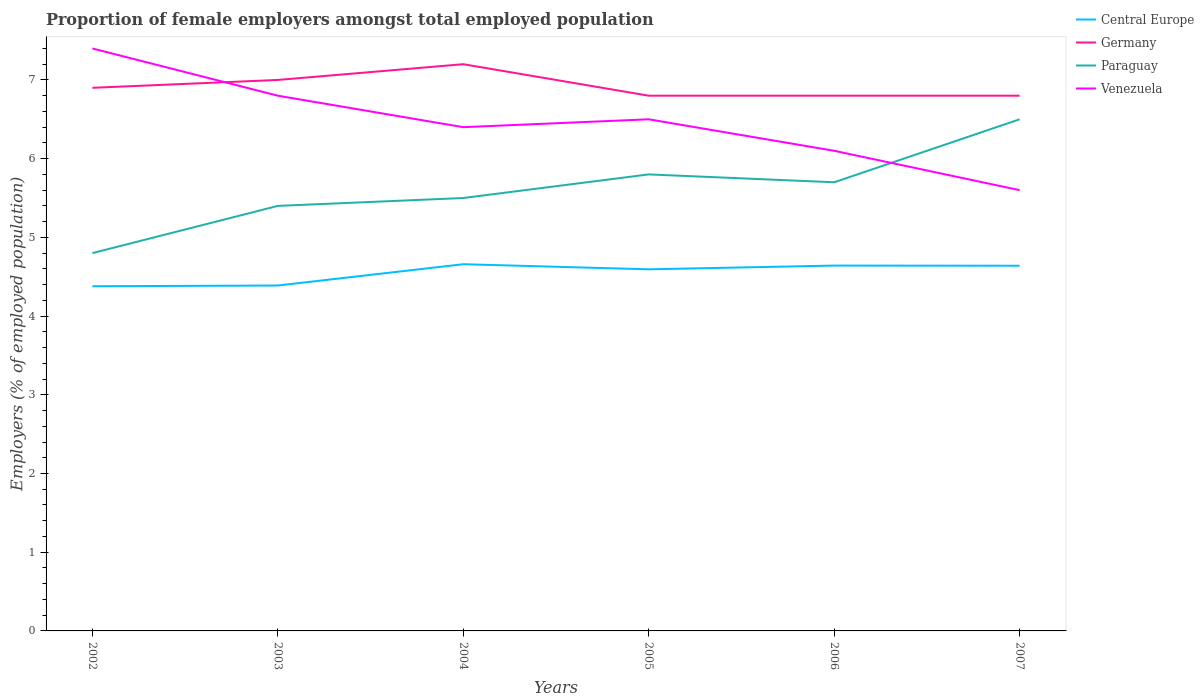How many different coloured lines are there?
Ensure brevity in your answer.  4. Does the line corresponding to Germany intersect with the line corresponding to Venezuela?
Your answer should be compact. Yes. Is the number of lines equal to the number of legend labels?
Ensure brevity in your answer.  Yes. Across all years, what is the maximum proportion of female employers in Paraguay?
Provide a short and direct response. 4.8. What is the total proportion of female employers in Germany in the graph?
Provide a succinct answer. 0.1. What is the difference between the highest and the second highest proportion of female employers in Venezuela?
Make the answer very short. 1.8. How many years are there in the graph?
Your answer should be very brief. 6. Are the values on the major ticks of Y-axis written in scientific E-notation?
Your answer should be very brief. No. Does the graph contain grids?
Provide a succinct answer. No. How are the legend labels stacked?
Provide a succinct answer. Vertical. What is the title of the graph?
Your response must be concise. Proportion of female employers amongst total employed population. Does "Saudi Arabia" appear as one of the legend labels in the graph?
Offer a very short reply. No. What is the label or title of the X-axis?
Your answer should be very brief. Years. What is the label or title of the Y-axis?
Provide a short and direct response. Employers (% of employed population). What is the Employers (% of employed population) of Central Europe in 2002?
Provide a short and direct response. 4.38. What is the Employers (% of employed population) in Germany in 2002?
Provide a short and direct response. 6.9. What is the Employers (% of employed population) of Paraguay in 2002?
Your answer should be compact. 4.8. What is the Employers (% of employed population) of Venezuela in 2002?
Keep it short and to the point. 7.4. What is the Employers (% of employed population) of Central Europe in 2003?
Your response must be concise. 4.39. What is the Employers (% of employed population) of Paraguay in 2003?
Make the answer very short. 5.4. What is the Employers (% of employed population) in Venezuela in 2003?
Provide a short and direct response. 6.8. What is the Employers (% of employed population) in Central Europe in 2004?
Keep it short and to the point. 4.66. What is the Employers (% of employed population) of Germany in 2004?
Provide a succinct answer. 7.2. What is the Employers (% of employed population) in Venezuela in 2004?
Provide a succinct answer. 6.4. What is the Employers (% of employed population) of Central Europe in 2005?
Provide a succinct answer. 4.59. What is the Employers (% of employed population) of Germany in 2005?
Your response must be concise. 6.8. What is the Employers (% of employed population) in Paraguay in 2005?
Provide a succinct answer. 5.8. What is the Employers (% of employed population) of Central Europe in 2006?
Provide a short and direct response. 4.64. What is the Employers (% of employed population) of Germany in 2006?
Your answer should be very brief. 6.8. What is the Employers (% of employed population) in Paraguay in 2006?
Keep it short and to the point. 5.7. What is the Employers (% of employed population) in Venezuela in 2006?
Provide a short and direct response. 6.1. What is the Employers (% of employed population) of Central Europe in 2007?
Provide a short and direct response. 4.64. What is the Employers (% of employed population) in Germany in 2007?
Make the answer very short. 6.8. What is the Employers (% of employed population) in Paraguay in 2007?
Your answer should be compact. 6.5. What is the Employers (% of employed population) of Venezuela in 2007?
Your response must be concise. 5.6. Across all years, what is the maximum Employers (% of employed population) in Central Europe?
Your answer should be compact. 4.66. Across all years, what is the maximum Employers (% of employed population) in Germany?
Make the answer very short. 7.2. Across all years, what is the maximum Employers (% of employed population) in Venezuela?
Provide a succinct answer. 7.4. Across all years, what is the minimum Employers (% of employed population) of Central Europe?
Your answer should be compact. 4.38. Across all years, what is the minimum Employers (% of employed population) in Germany?
Offer a very short reply. 6.8. Across all years, what is the minimum Employers (% of employed population) of Paraguay?
Provide a short and direct response. 4.8. Across all years, what is the minimum Employers (% of employed population) in Venezuela?
Your response must be concise. 5.6. What is the total Employers (% of employed population) in Central Europe in the graph?
Give a very brief answer. 27.3. What is the total Employers (% of employed population) of Germany in the graph?
Give a very brief answer. 41.5. What is the total Employers (% of employed population) in Paraguay in the graph?
Ensure brevity in your answer.  33.7. What is the total Employers (% of employed population) of Venezuela in the graph?
Your answer should be compact. 38.8. What is the difference between the Employers (% of employed population) of Central Europe in 2002 and that in 2003?
Your response must be concise. -0.01. What is the difference between the Employers (% of employed population) in Germany in 2002 and that in 2003?
Ensure brevity in your answer.  -0.1. What is the difference between the Employers (% of employed population) of Paraguay in 2002 and that in 2003?
Provide a short and direct response. -0.6. What is the difference between the Employers (% of employed population) in Venezuela in 2002 and that in 2003?
Your answer should be very brief. 0.6. What is the difference between the Employers (% of employed population) of Central Europe in 2002 and that in 2004?
Your answer should be very brief. -0.28. What is the difference between the Employers (% of employed population) of Germany in 2002 and that in 2004?
Provide a short and direct response. -0.3. What is the difference between the Employers (% of employed population) in Paraguay in 2002 and that in 2004?
Offer a very short reply. -0.7. What is the difference between the Employers (% of employed population) of Central Europe in 2002 and that in 2005?
Offer a terse response. -0.22. What is the difference between the Employers (% of employed population) in Central Europe in 2002 and that in 2006?
Keep it short and to the point. -0.26. What is the difference between the Employers (% of employed population) of Paraguay in 2002 and that in 2006?
Ensure brevity in your answer.  -0.9. What is the difference between the Employers (% of employed population) in Central Europe in 2002 and that in 2007?
Provide a succinct answer. -0.26. What is the difference between the Employers (% of employed population) in Germany in 2002 and that in 2007?
Your answer should be very brief. 0.1. What is the difference between the Employers (% of employed population) of Paraguay in 2002 and that in 2007?
Give a very brief answer. -1.7. What is the difference between the Employers (% of employed population) of Venezuela in 2002 and that in 2007?
Ensure brevity in your answer.  1.8. What is the difference between the Employers (% of employed population) in Central Europe in 2003 and that in 2004?
Give a very brief answer. -0.27. What is the difference between the Employers (% of employed population) of Germany in 2003 and that in 2004?
Your response must be concise. -0.2. What is the difference between the Employers (% of employed population) of Paraguay in 2003 and that in 2004?
Ensure brevity in your answer.  -0.1. What is the difference between the Employers (% of employed population) of Venezuela in 2003 and that in 2004?
Your response must be concise. 0.4. What is the difference between the Employers (% of employed population) of Central Europe in 2003 and that in 2005?
Offer a terse response. -0.21. What is the difference between the Employers (% of employed population) in Germany in 2003 and that in 2005?
Make the answer very short. 0.2. What is the difference between the Employers (% of employed population) of Paraguay in 2003 and that in 2005?
Give a very brief answer. -0.4. What is the difference between the Employers (% of employed population) in Central Europe in 2003 and that in 2006?
Provide a short and direct response. -0.25. What is the difference between the Employers (% of employed population) in Germany in 2003 and that in 2006?
Give a very brief answer. 0.2. What is the difference between the Employers (% of employed population) in Central Europe in 2003 and that in 2007?
Make the answer very short. -0.25. What is the difference between the Employers (% of employed population) in Paraguay in 2003 and that in 2007?
Offer a very short reply. -1.1. What is the difference between the Employers (% of employed population) in Central Europe in 2004 and that in 2005?
Your response must be concise. 0.06. What is the difference between the Employers (% of employed population) in Germany in 2004 and that in 2005?
Provide a short and direct response. 0.4. What is the difference between the Employers (% of employed population) in Paraguay in 2004 and that in 2005?
Give a very brief answer. -0.3. What is the difference between the Employers (% of employed population) in Central Europe in 2004 and that in 2006?
Your response must be concise. 0.02. What is the difference between the Employers (% of employed population) in Central Europe in 2004 and that in 2007?
Provide a succinct answer. 0.02. What is the difference between the Employers (% of employed population) in Venezuela in 2004 and that in 2007?
Your answer should be very brief. 0.8. What is the difference between the Employers (% of employed population) of Central Europe in 2005 and that in 2006?
Keep it short and to the point. -0.05. What is the difference between the Employers (% of employed population) of Germany in 2005 and that in 2006?
Your response must be concise. 0. What is the difference between the Employers (% of employed population) of Central Europe in 2005 and that in 2007?
Make the answer very short. -0.05. What is the difference between the Employers (% of employed population) of Paraguay in 2005 and that in 2007?
Offer a very short reply. -0.7. What is the difference between the Employers (% of employed population) in Central Europe in 2006 and that in 2007?
Give a very brief answer. 0. What is the difference between the Employers (% of employed population) of Germany in 2006 and that in 2007?
Your answer should be compact. 0. What is the difference between the Employers (% of employed population) in Venezuela in 2006 and that in 2007?
Your response must be concise. 0.5. What is the difference between the Employers (% of employed population) of Central Europe in 2002 and the Employers (% of employed population) of Germany in 2003?
Your answer should be compact. -2.62. What is the difference between the Employers (% of employed population) in Central Europe in 2002 and the Employers (% of employed population) in Paraguay in 2003?
Offer a terse response. -1.02. What is the difference between the Employers (% of employed population) in Central Europe in 2002 and the Employers (% of employed population) in Venezuela in 2003?
Your answer should be very brief. -2.42. What is the difference between the Employers (% of employed population) of Germany in 2002 and the Employers (% of employed population) of Paraguay in 2003?
Make the answer very short. 1.5. What is the difference between the Employers (% of employed population) in Paraguay in 2002 and the Employers (% of employed population) in Venezuela in 2003?
Provide a short and direct response. -2. What is the difference between the Employers (% of employed population) in Central Europe in 2002 and the Employers (% of employed population) in Germany in 2004?
Offer a very short reply. -2.82. What is the difference between the Employers (% of employed population) in Central Europe in 2002 and the Employers (% of employed population) in Paraguay in 2004?
Keep it short and to the point. -1.12. What is the difference between the Employers (% of employed population) in Central Europe in 2002 and the Employers (% of employed population) in Venezuela in 2004?
Provide a succinct answer. -2.02. What is the difference between the Employers (% of employed population) of Germany in 2002 and the Employers (% of employed population) of Paraguay in 2004?
Your answer should be compact. 1.4. What is the difference between the Employers (% of employed population) in Germany in 2002 and the Employers (% of employed population) in Venezuela in 2004?
Keep it short and to the point. 0.5. What is the difference between the Employers (% of employed population) of Central Europe in 2002 and the Employers (% of employed population) of Germany in 2005?
Provide a succinct answer. -2.42. What is the difference between the Employers (% of employed population) of Central Europe in 2002 and the Employers (% of employed population) of Paraguay in 2005?
Keep it short and to the point. -1.42. What is the difference between the Employers (% of employed population) in Central Europe in 2002 and the Employers (% of employed population) in Venezuela in 2005?
Give a very brief answer. -2.12. What is the difference between the Employers (% of employed population) in Paraguay in 2002 and the Employers (% of employed population) in Venezuela in 2005?
Ensure brevity in your answer.  -1.7. What is the difference between the Employers (% of employed population) in Central Europe in 2002 and the Employers (% of employed population) in Germany in 2006?
Ensure brevity in your answer.  -2.42. What is the difference between the Employers (% of employed population) in Central Europe in 2002 and the Employers (% of employed population) in Paraguay in 2006?
Your answer should be compact. -1.32. What is the difference between the Employers (% of employed population) of Central Europe in 2002 and the Employers (% of employed population) of Venezuela in 2006?
Make the answer very short. -1.72. What is the difference between the Employers (% of employed population) in Germany in 2002 and the Employers (% of employed population) in Paraguay in 2006?
Your answer should be very brief. 1.2. What is the difference between the Employers (% of employed population) of Paraguay in 2002 and the Employers (% of employed population) of Venezuela in 2006?
Make the answer very short. -1.3. What is the difference between the Employers (% of employed population) of Central Europe in 2002 and the Employers (% of employed population) of Germany in 2007?
Ensure brevity in your answer.  -2.42. What is the difference between the Employers (% of employed population) of Central Europe in 2002 and the Employers (% of employed population) of Paraguay in 2007?
Offer a very short reply. -2.12. What is the difference between the Employers (% of employed population) of Central Europe in 2002 and the Employers (% of employed population) of Venezuela in 2007?
Your answer should be compact. -1.22. What is the difference between the Employers (% of employed population) in Germany in 2002 and the Employers (% of employed population) in Venezuela in 2007?
Provide a succinct answer. 1.3. What is the difference between the Employers (% of employed population) of Paraguay in 2002 and the Employers (% of employed population) of Venezuela in 2007?
Your answer should be compact. -0.8. What is the difference between the Employers (% of employed population) in Central Europe in 2003 and the Employers (% of employed population) in Germany in 2004?
Offer a terse response. -2.81. What is the difference between the Employers (% of employed population) of Central Europe in 2003 and the Employers (% of employed population) of Paraguay in 2004?
Your answer should be very brief. -1.11. What is the difference between the Employers (% of employed population) of Central Europe in 2003 and the Employers (% of employed population) of Venezuela in 2004?
Your answer should be compact. -2.01. What is the difference between the Employers (% of employed population) of Germany in 2003 and the Employers (% of employed population) of Venezuela in 2004?
Offer a very short reply. 0.6. What is the difference between the Employers (% of employed population) in Central Europe in 2003 and the Employers (% of employed population) in Germany in 2005?
Keep it short and to the point. -2.41. What is the difference between the Employers (% of employed population) of Central Europe in 2003 and the Employers (% of employed population) of Paraguay in 2005?
Make the answer very short. -1.41. What is the difference between the Employers (% of employed population) of Central Europe in 2003 and the Employers (% of employed population) of Venezuela in 2005?
Offer a terse response. -2.11. What is the difference between the Employers (% of employed population) in Germany in 2003 and the Employers (% of employed population) in Paraguay in 2005?
Offer a very short reply. 1.2. What is the difference between the Employers (% of employed population) of Paraguay in 2003 and the Employers (% of employed population) of Venezuela in 2005?
Keep it short and to the point. -1.1. What is the difference between the Employers (% of employed population) in Central Europe in 2003 and the Employers (% of employed population) in Germany in 2006?
Your answer should be very brief. -2.41. What is the difference between the Employers (% of employed population) in Central Europe in 2003 and the Employers (% of employed population) in Paraguay in 2006?
Offer a very short reply. -1.31. What is the difference between the Employers (% of employed population) of Central Europe in 2003 and the Employers (% of employed population) of Venezuela in 2006?
Keep it short and to the point. -1.71. What is the difference between the Employers (% of employed population) in Central Europe in 2003 and the Employers (% of employed population) in Germany in 2007?
Offer a very short reply. -2.41. What is the difference between the Employers (% of employed population) in Central Europe in 2003 and the Employers (% of employed population) in Paraguay in 2007?
Your answer should be very brief. -2.11. What is the difference between the Employers (% of employed population) of Central Europe in 2003 and the Employers (% of employed population) of Venezuela in 2007?
Give a very brief answer. -1.21. What is the difference between the Employers (% of employed population) of Germany in 2003 and the Employers (% of employed population) of Paraguay in 2007?
Ensure brevity in your answer.  0.5. What is the difference between the Employers (% of employed population) in Paraguay in 2003 and the Employers (% of employed population) in Venezuela in 2007?
Give a very brief answer. -0.2. What is the difference between the Employers (% of employed population) of Central Europe in 2004 and the Employers (% of employed population) of Germany in 2005?
Your answer should be compact. -2.14. What is the difference between the Employers (% of employed population) in Central Europe in 2004 and the Employers (% of employed population) in Paraguay in 2005?
Offer a terse response. -1.14. What is the difference between the Employers (% of employed population) of Central Europe in 2004 and the Employers (% of employed population) of Venezuela in 2005?
Your answer should be compact. -1.84. What is the difference between the Employers (% of employed population) in Central Europe in 2004 and the Employers (% of employed population) in Germany in 2006?
Offer a terse response. -2.14. What is the difference between the Employers (% of employed population) in Central Europe in 2004 and the Employers (% of employed population) in Paraguay in 2006?
Offer a terse response. -1.04. What is the difference between the Employers (% of employed population) of Central Europe in 2004 and the Employers (% of employed population) of Venezuela in 2006?
Ensure brevity in your answer.  -1.44. What is the difference between the Employers (% of employed population) in Germany in 2004 and the Employers (% of employed population) in Paraguay in 2006?
Give a very brief answer. 1.5. What is the difference between the Employers (% of employed population) in Central Europe in 2004 and the Employers (% of employed population) in Germany in 2007?
Offer a very short reply. -2.14. What is the difference between the Employers (% of employed population) in Central Europe in 2004 and the Employers (% of employed population) in Paraguay in 2007?
Your answer should be very brief. -1.84. What is the difference between the Employers (% of employed population) in Central Europe in 2004 and the Employers (% of employed population) in Venezuela in 2007?
Ensure brevity in your answer.  -0.94. What is the difference between the Employers (% of employed population) of Germany in 2004 and the Employers (% of employed population) of Paraguay in 2007?
Provide a short and direct response. 0.7. What is the difference between the Employers (% of employed population) of Germany in 2004 and the Employers (% of employed population) of Venezuela in 2007?
Your answer should be very brief. 1.6. What is the difference between the Employers (% of employed population) in Paraguay in 2004 and the Employers (% of employed population) in Venezuela in 2007?
Offer a terse response. -0.1. What is the difference between the Employers (% of employed population) in Central Europe in 2005 and the Employers (% of employed population) in Germany in 2006?
Your answer should be compact. -2.21. What is the difference between the Employers (% of employed population) in Central Europe in 2005 and the Employers (% of employed population) in Paraguay in 2006?
Give a very brief answer. -1.11. What is the difference between the Employers (% of employed population) of Central Europe in 2005 and the Employers (% of employed population) of Venezuela in 2006?
Ensure brevity in your answer.  -1.51. What is the difference between the Employers (% of employed population) of Germany in 2005 and the Employers (% of employed population) of Venezuela in 2006?
Offer a very short reply. 0.7. What is the difference between the Employers (% of employed population) in Central Europe in 2005 and the Employers (% of employed population) in Germany in 2007?
Your answer should be compact. -2.21. What is the difference between the Employers (% of employed population) in Central Europe in 2005 and the Employers (% of employed population) in Paraguay in 2007?
Keep it short and to the point. -1.91. What is the difference between the Employers (% of employed population) of Central Europe in 2005 and the Employers (% of employed population) of Venezuela in 2007?
Provide a succinct answer. -1.01. What is the difference between the Employers (% of employed population) in Germany in 2005 and the Employers (% of employed population) in Venezuela in 2007?
Offer a very short reply. 1.2. What is the difference between the Employers (% of employed population) in Paraguay in 2005 and the Employers (% of employed population) in Venezuela in 2007?
Ensure brevity in your answer.  0.2. What is the difference between the Employers (% of employed population) of Central Europe in 2006 and the Employers (% of employed population) of Germany in 2007?
Make the answer very short. -2.16. What is the difference between the Employers (% of employed population) of Central Europe in 2006 and the Employers (% of employed population) of Paraguay in 2007?
Ensure brevity in your answer.  -1.86. What is the difference between the Employers (% of employed population) of Central Europe in 2006 and the Employers (% of employed population) of Venezuela in 2007?
Offer a terse response. -0.96. What is the difference between the Employers (% of employed population) in Paraguay in 2006 and the Employers (% of employed population) in Venezuela in 2007?
Provide a short and direct response. 0.1. What is the average Employers (% of employed population) of Central Europe per year?
Offer a very short reply. 4.55. What is the average Employers (% of employed population) of Germany per year?
Offer a very short reply. 6.92. What is the average Employers (% of employed population) in Paraguay per year?
Your answer should be very brief. 5.62. What is the average Employers (% of employed population) of Venezuela per year?
Make the answer very short. 6.47. In the year 2002, what is the difference between the Employers (% of employed population) of Central Europe and Employers (% of employed population) of Germany?
Provide a succinct answer. -2.52. In the year 2002, what is the difference between the Employers (% of employed population) in Central Europe and Employers (% of employed population) in Paraguay?
Your answer should be compact. -0.42. In the year 2002, what is the difference between the Employers (% of employed population) of Central Europe and Employers (% of employed population) of Venezuela?
Offer a very short reply. -3.02. In the year 2002, what is the difference between the Employers (% of employed population) of Paraguay and Employers (% of employed population) of Venezuela?
Offer a terse response. -2.6. In the year 2003, what is the difference between the Employers (% of employed population) in Central Europe and Employers (% of employed population) in Germany?
Offer a very short reply. -2.61. In the year 2003, what is the difference between the Employers (% of employed population) in Central Europe and Employers (% of employed population) in Paraguay?
Provide a succinct answer. -1.01. In the year 2003, what is the difference between the Employers (% of employed population) of Central Europe and Employers (% of employed population) of Venezuela?
Your response must be concise. -2.41. In the year 2003, what is the difference between the Employers (% of employed population) in Germany and Employers (% of employed population) in Paraguay?
Your response must be concise. 1.6. In the year 2003, what is the difference between the Employers (% of employed population) in Germany and Employers (% of employed population) in Venezuela?
Your answer should be very brief. 0.2. In the year 2003, what is the difference between the Employers (% of employed population) of Paraguay and Employers (% of employed population) of Venezuela?
Give a very brief answer. -1.4. In the year 2004, what is the difference between the Employers (% of employed population) in Central Europe and Employers (% of employed population) in Germany?
Provide a short and direct response. -2.54. In the year 2004, what is the difference between the Employers (% of employed population) of Central Europe and Employers (% of employed population) of Paraguay?
Provide a short and direct response. -0.84. In the year 2004, what is the difference between the Employers (% of employed population) of Central Europe and Employers (% of employed population) of Venezuela?
Your response must be concise. -1.74. In the year 2004, what is the difference between the Employers (% of employed population) of Germany and Employers (% of employed population) of Paraguay?
Give a very brief answer. 1.7. In the year 2004, what is the difference between the Employers (% of employed population) of Germany and Employers (% of employed population) of Venezuela?
Your answer should be compact. 0.8. In the year 2005, what is the difference between the Employers (% of employed population) in Central Europe and Employers (% of employed population) in Germany?
Your response must be concise. -2.21. In the year 2005, what is the difference between the Employers (% of employed population) in Central Europe and Employers (% of employed population) in Paraguay?
Provide a short and direct response. -1.21. In the year 2005, what is the difference between the Employers (% of employed population) in Central Europe and Employers (% of employed population) in Venezuela?
Offer a very short reply. -1.91. In the year 2005, what is the difference between the Employers (% of employed population) of Germany and Employers (% of employed population) of Paraguay?
Your answer should be very brief. 1. In the year 2006, what is the difference between the Employers (% of employed population) in Central Europe and Employers (% of employed population) in Germany?
Ensure brevity in your answer.  -2.16. In the year 2006, what is the difference between the Employers (% of employed population) of Central Europe and Employers (% of employed population) of Paraguay?
Provide a short and direct response. -1.06. In the year 2006, what is the difference between the Employers (% of employed population) of Central Europe and Employers (% of employed population) of Venezuela?
Keep it short and to the point. -1.46. In the year 2006, what is the difference between the Employers (% of employed population) in Germany and Employers (% of employed population) in Venezuela?
Keep it short and to the point. 0.7. In the year 2006, what is the difference between the Employers (% of employed population) in Paraguay and Employers (% of employed population) in Venezuela?
Your answer should be very brief. -0.4. In the year 2007, what is the difference between the Employers (% of employed population) of Central Europe and Employers (% of employed population) of Germany?
Give a very brief answer. -2.16. In the year 2007, what is the difference between the Employers (% of employed population) in Central Europe and Employers (% of employed population) in Paraguay?
Your response must be concise. -1.86. In the year 2007, what is the difference between the Employers (% of employed population) of Central Europe and Employers (% of employed population) of Venezuela?
Your response must be concise. -0.96. In the year 2007, what is the difference between the Employers (% of employed population) of Germany and Employers (% of employed population) of Paraguay?
Keep it short and to the point. 0.3. What is the ratio of the Employers (% of employed population) of Central Europe in 2002 to that in 2003?
Offer a terse response. 1. What is the ratio of the Employers (% of employed population) of Germany in 2002 to that in 2003?
Your response must be concise. 0.99. What is the ratio of the Employers (% of employed population) of Paraguay in 2002 to that in 2003?
Your answer should be compact. 0.89. What is the ratio of the Employers (% of employed population) in Venezuela in 2002 to that in 2003?
Your answer should be very brief. 1.09. What is the ratio of the Employers (% of employed population) in Central Europe in 2002 to that in 2004?
Give a very brief answer. 0.94. What is the ratio of the Employers (% of employed population) in Paraguay in 2002 to that in 2004?
Provide a short and direct response. 0.87. What is the ratio of the Employers (% of employed population) in Venezuela in 2002 to that in 2004?
Give a very brief answer. 1.16. What is the ratio of the Employers (% of employed population) of Central Europe in 2002 to that in 2005?
Your answer should be compact. 0.95. What is the ratio of the Employers (% of employed population) in Germany in 2002 to that in 2005?
Offer a very short reply. 1.01. What is the ratio of the Employers (% of employed population) in Paraguay in 2002 to that in 2005?
Offer a terse response. 0.83. What is the ratio of the Employers (% of employed population) of Venezuela in 2002 to that in 2005?
Offer a very short reply. 1.14. What is the ratio of the Employers (% of employed population) of Central Europe in 2002 to that in 2006?
Provide a short and direct response. 0.94. What is the ratio of the Employers (% of employed population) in Germany in 2002 to that in 2006?
Your answer should be compact. 1.01. What is the ratio of the Employers (% of employed population) in Paraguay in 2002 to that in 2006?
Provide a succinct answer. 0.84. What is the ratio of the Employers (% of employed population) in Venezuela in 2002 to that in 2006?
Offer a very short reply. 1.21. What is the ratio of the Employers (% of employed population) in Central Europe in 2002 to that in 2007?
Ensure brevity in your answer.  0.94. What is the ratio of the Employers (% of employed population) of Germany in 2002 to that in 2007?
Your response must be concise. 1.01. What is the ratio of the Employers (% of employed population) in Paraguay in 2002 to that in 2007?
Ensure brevity in your answer.  0.74. What is the ratio of the Employers (% of employed population) in Venezuela in 2002 to that in 2007?
Keep it short and to the point. 1.32. What is the ratio of the Employers (% of employed population) in Central Europe in 2003 to that in 2004?
Your answer should be very brief. 0.94. What is the ratio of the Employers (% of employed population) in Germany in 2003 to that in 2004?
Provide a short and direct response. 0.97. What is the ratio of the Employers (% of employed population) of Paraguay in 2003 to that in 2004?
Your answer should be very brief. 0.98. What is the ratio of the Employers (% of employed population) of Central Europe in 2003 to that in 2005?
Offer a terse response. 0.96. What is the ratio of the Employers (% of employed population) of Germany in 2003 to that in 2005?
Your answer should be compact. 1.03. What is the ratio of the Employers (% of employed population) of Paraguay in 2003 to that in 2005?
Make the answer very short. 0.93. What is the ratio of the Employers (% of employed population) of Venezuela in 2003 to that in 2005?
Make the answer very short. 1.05. What is the ratio of the Employers (% of employed population) of Central Europe in 2003 to that in 2006?
Offer a terse response. 0.95. What is the ratio of the Employers (% of employed population) of Germany in 2003 to that in 2006?
Make the answer very short. 1.03. What is the ratio of the Employers (% of employed population) of Paraguay in 2003 to that in 2006?
Provide a succinct answer. 0.95. What is the ratio of the Employers (% of employed population) in Venezuela in 2003 to that in 2006?
Your answer should be very brief. 1.11. What is the ratio of the Employers (% of employed population) in Central Europe in 2003 to that in 2007?
Ensure brevity in your answer.  0.95. What is the ratio of the Employers (% of employed population) of Germany in 2003 to that in 2007?
Offer a terse response. 1.03. What is the ratio of the Employers (% of employed population) of Paraguay in 2003 to that in 2007?
Give a very brief answer. 0.83. What is the ratio of the Employers (% of employed population) in Venezuela in 2003 to that in 2007?
Give a very brief answer. 1.21. What is the ratio of the Employers (% of employed population) in Central Europe in 2004 to that in 2005?
Your response must be concise. 1.01. What is the ratio of the Employers (% of employed population) in Germany in 2004 to that in 2005?
Make the answer very short. 1.06. What is the ratio of the Employers (% of employed population) of Paraguay in 2004 to that in 2005?
Give a very brief answer. 0.95. What is the ratio of the Employers (% of employed population) in Venezuela in 2004 to that in 2005?
Offer a terse response. 0.98. What is the ratio of the Employers (% of employed population) in Germany in 2004 to that in 2006?
Your response must be concise. 1.06. What is the ratio of the Employers (% of employed population) in Paraguay in 2004 to that in 2006?
Provide a short and direct response. 0.96. What is the ratio of the Employers (% of employed population) in Venezuela in 2004 to that in 2006?
Ensure brevity in your answer.  1.05. What is the ratio of the Employers (% of employed population) in Germany in 2004 to that in 2007?
Provide a succinct answer. 1.06. What is the ratio of the Employers (% of employed population) of Paraguay in 2004 to that in 2007?
Your answer should be very brief. 0.85. What is the ratio of the Employers (% of employed population) in Paraguay in 2005 to that in 2006?
Provide a short and direct response. 1.02. What is the ratio of the Employers (% of employed population) in Venezuela in 2005 to that in 2006?
Make the answer very short. 1.07. What is the ratio of the Employers (% of employed population) in Central Europe in 2005 to that in 2007?
Offer a terse response. 0.99. What is the ratio of the Employers (% of employed population) in Paraguay in 2005 to that in 2007?
Offer a very short reply. 0.89. What is the ratio of the Employers (% of employed population) of Venezuela in 2005 to that in 2007?
Provide a short and direct response. 1.16. What is the ratio of the Employers (% of employed population) of Germany in 2006 to that in 2007?
Keep it short and to the point. 1. What is the ratio of the Employers (% of employed population) of Paraguay in 2006 to that in 2007?
Give a very brief answer. 0.88. What is the ratio of the Employers (% of employed population) of Venezuela in 2006 to that in 2007?
Provide a succinct answer. 1.09. What is the difference between the highest and the second highest Employers (% of employed population) of Central Europe?
Your answer should be very brief. 0.02. What is the difference between the highest and the second highest Employers (% of employed population) in Paraguay?
Your answer should be very brief. 0.7. What is the difference between the highest and the second highest Employers (% of employed population) in Venezuela?
Your response must be concise. 0.6. What is the difference between the highest and the lowest Employers (% of employed population) of Central Europe?
Provide a succinct answer. 0.28. What is the difference between the highest and the lowest Employers (% of employed population) of Germany?
Your answer should be compact. 0.4. What is the difference between the highest and the lowest Employers (% of employed population) of Paraguay?
Your response must be concise. 1.7. 